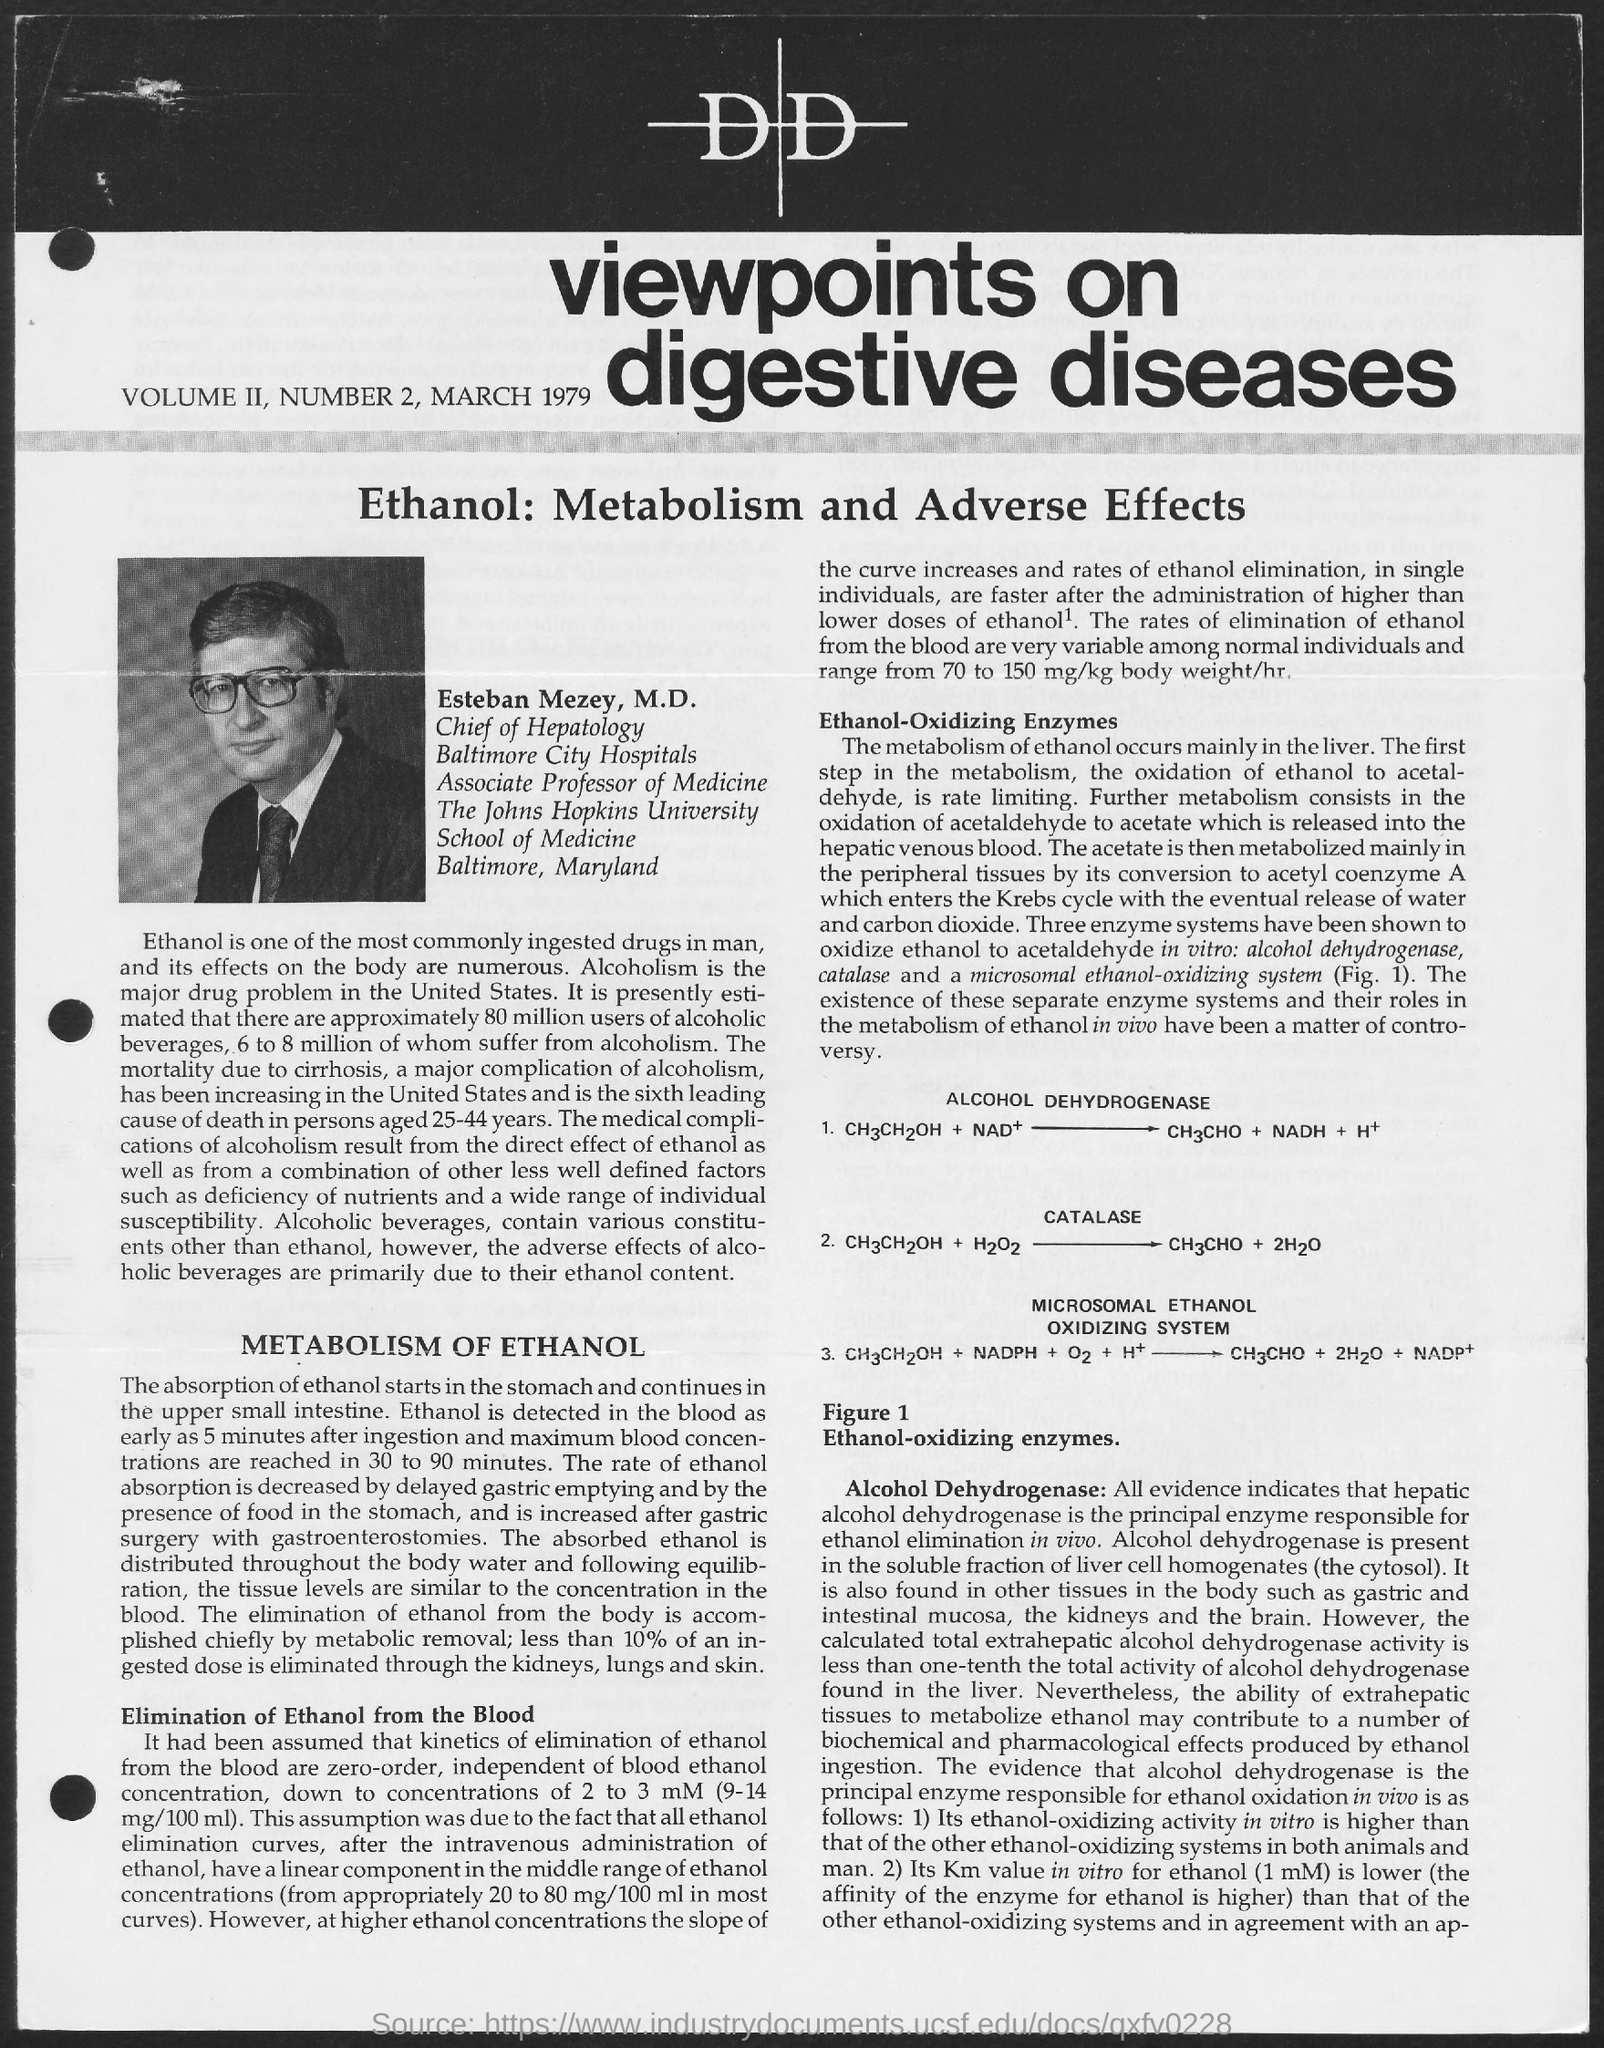Outline some significant characteristics in this image. The date on the document is March 1979. 